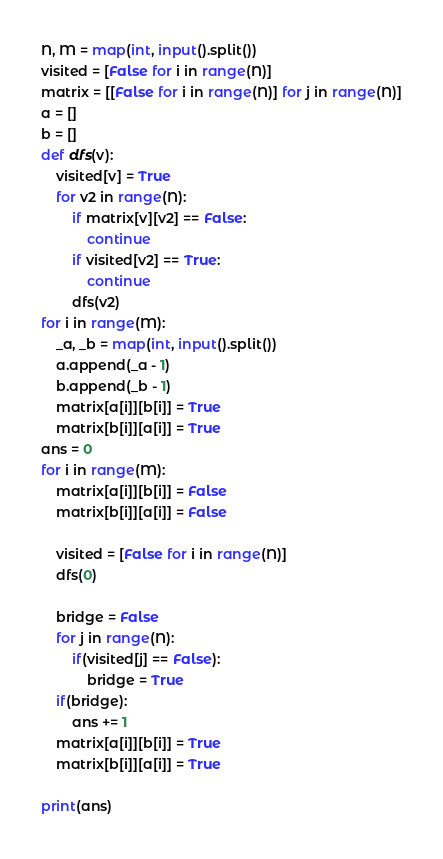Convert code to text. <code><loc_0><loc_0><loc_500><loc_500><_Python_>N, M = map(int, input().split())
visited = [False for i in range(N)]
matrix = [[False for i in range(N)] for j in range(N)]
a = []
b = []
def dfs(v):
    visited[v] = True
    for v2 in range(N):
        if matrix[v][v2] == False:
            continue
        if visited[v2] == True:
            continue
        dfs(v2)
for i in range(M):
    _a, _b = map(int, input().split())
    a.append(_a - 1)
    b.append(_b - 1)
    matrix[a[i]][b[i]] = True
    matrix[b[i]][a[i]] = True
ans = 0
for i in range(M):
    matrix[a[i]][b[i]] = False
    matrix[b[i]][a[i]] = False

    visited = [False for i in range(N)]
    dfs(0)

    bridge = False
    for j in range(N):
        if(visited[j] == False):
            bridge = True
    if(bridge):
        ans += 1
    matrix[a[i]][b[i]] = True
    matrix[b[i]][a[i]] = True

print(ans)
</code> 